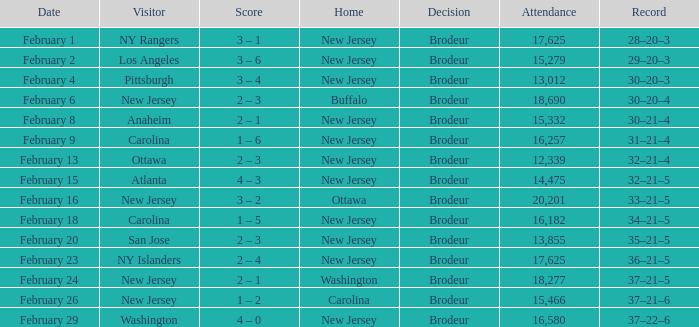What was the outcome when the visiting side was ottawa? 32–21–4. 